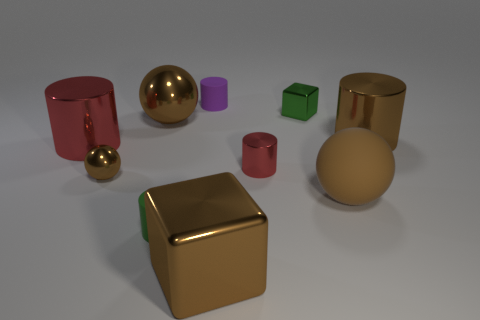Subtract all brown balls. How many were subtracted if there are1brown balls left? 2 Subtract all green cylinders. How many cylinders are left? 4 Subtract all metallic spheres. How many spheres are left? 1 Subtract all cyan cylinders. Subtract all green balls. How many cylinders are left? 5 Subtract all balls. How many objects are left? 7 Subtract 0 yellow cylinders. How many objects are left? 10 Subtract all small cubes. Subtract all cyan metal balls. How many objects are left? 9 Add 9 tiny green cylinders. How many tiny green cylinders are left? 10 Add 4 tiny metallic objects. How many tiny metallic objects exist? 7 